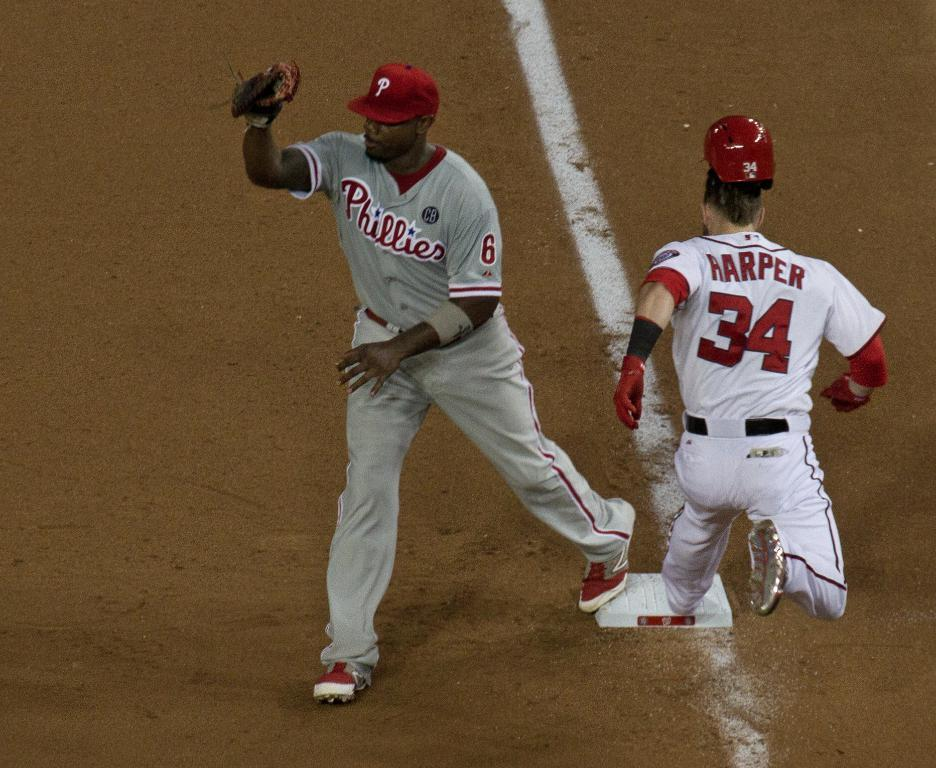<image>
Offer a succinct explanation of the picture presented. A player named Harper races in to make the base in time before a Phillies player can tag him out. 